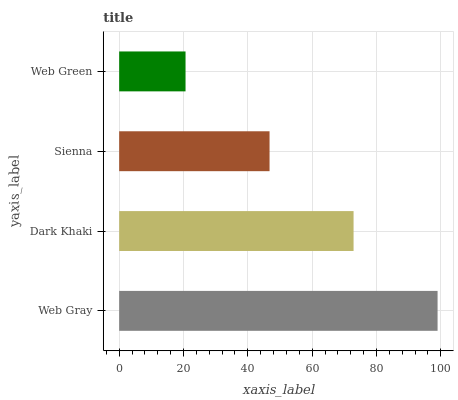Is Web Green the minimum?
Answer yes or no. Yes. Is Web Gray the maximum?
Answer yes or no. Yes. Is Dark Khaki the minimum?
Answer yes or no. No. Is Dark Khaki the maximum?
Answer yes or no. No. Is Web Gray greater than Dark Khaki?
Answer yes or no. Yes. Is Dark Khaki less than Web Gray?
Answer yes or no. Yes. Is Dark Khaki greater than Web Gray?
Answer yes or no. No. Is Web Gray less than Dark Khaki?
Answer yes or no. No. Is Dark Khaki the high median?
Answer yes or no. Yes. Is Sienna the low median?
Answer yes or no. Yes. Is Web Green the high median?
Answer yes or no. No. Is Web Gray the low median?
Answer yes or no. No. 